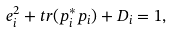Convert formula to latex. <formula><loc_0><loc_0><loc_500><loc_500>e _ { i } ^ { 2 } + t r ( { p } _ { i } ^ { * } { p } _ { i } ) + D _ { i } = 1 ,</formula> 